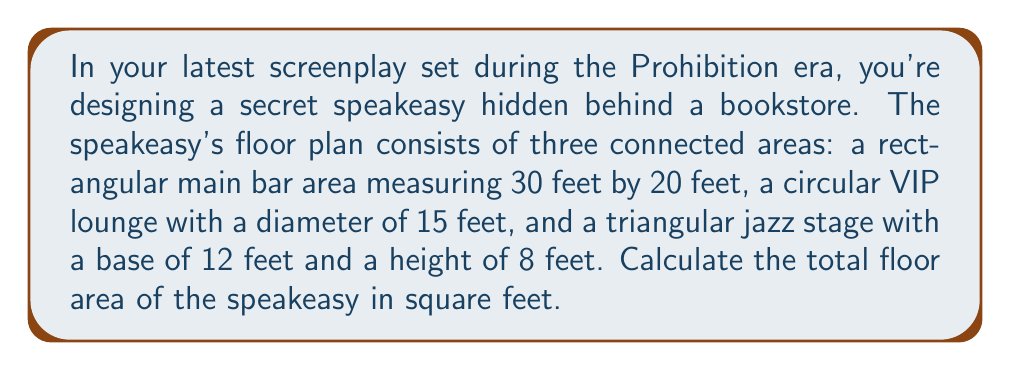What is the answer to this math problem? To solve this problem, we need to calculate the area of each section and then sum them up:

1. Rectangular main bar area:
   Area of a rectangle = length × width
   $A_{rectangle} = 30 \text{ ft} \times 20 \text{ ft} = 600 \text{ sq ft}$

2. Circular VIP lounge:
   Area of a circle = $\pi r^2$, where $r$ is the radius (half the diameter)
   $r = 15 \text{ ft} \div 2 = 7.5 \text{ ft}$
   $A_{circle} = \pi (7.5 \text{ ft})^2 \approx 176.71 \text{ sq ft}$

3. Triangular jazz stage:
   Area of a triangle = $\frac{1}{2} \times \text{base} \times \text{height}$
   $A_{triangle} = \frac{1}{2} \times 12 \text{ ft} \times 8 \text{ ft} = 48 \text{ sq ft}$

Total area:
$$A_{total} = A_{rectangle} + A_{circle} + A_{triangle}$$
$$A_{total} = 600 \text{ sq ft} + 176.71 \text{ sq ft} + 48 \text{ sq ft} = 824.71 \text{ sq ft}$$

[asy]
import geometry;

// Main bar area
draw((0,0)--(30,0)--(30,20)--(0,20)--cycle);
label("30 ft", (15,0), S);
label("20 ft", (30,10), E);
label("Main Bar", (15,10));

// VIP lounge
draw(circle((40,10),7.5));
label("VIP Lounge", (40,10));
draw((40,10)--(47.5,10));
label("7.5 ft", (43.75,10), N);

// Jazz stage
draw((0,20)--(12,20)--(6,28)--cycle);
label("Jazz Stage", (6,23));
label("12 ft", (6,20), S);
draw((6,20)--(6,28));
label("8 ft", (6,24), E);

[/asy]
Answer: The total floor area of the speakeasy is approximately 824.71 square feet. 